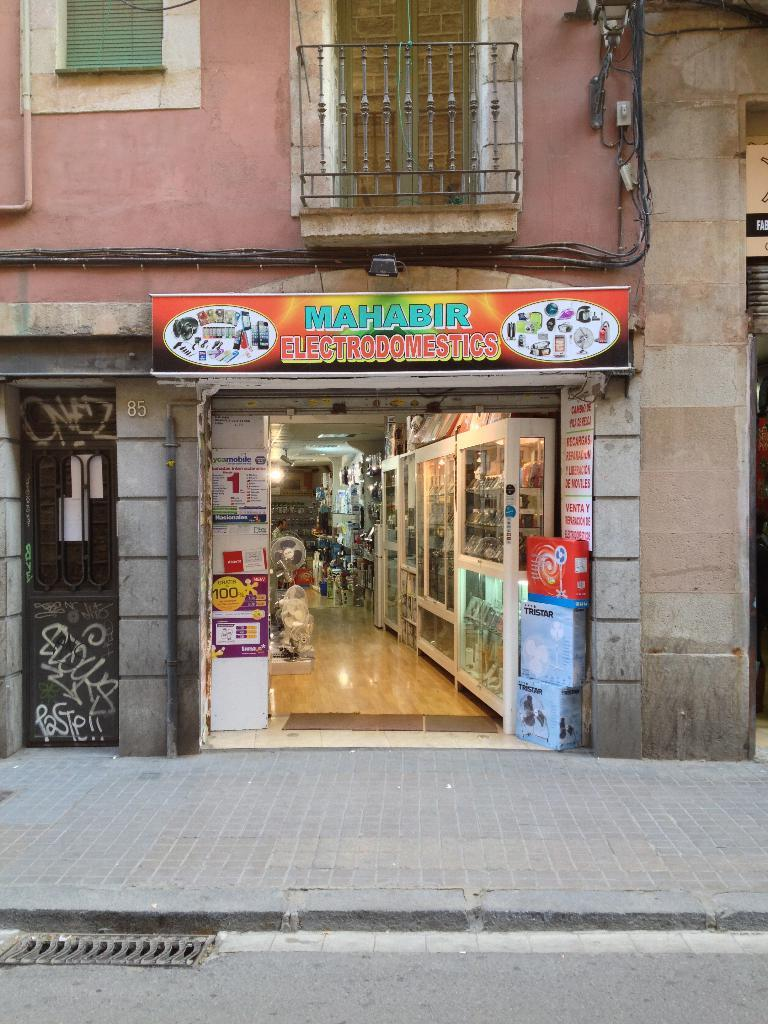<image>
Present a compact description of the photo's key features. The entrance to Mahabir Electrodomestics has a sign above it. 